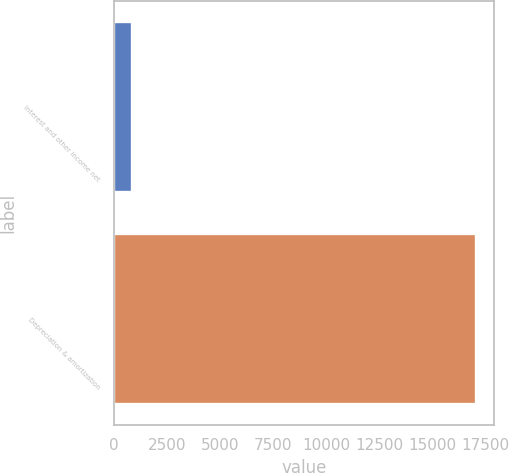<chart> <loc_0><loc_0><loc_500><loc_500><bar_chart><fcel>Interest and other income net<fcel>Depreciation & amortization<nl><fcel>847<fcel>17032<nl></chart> 